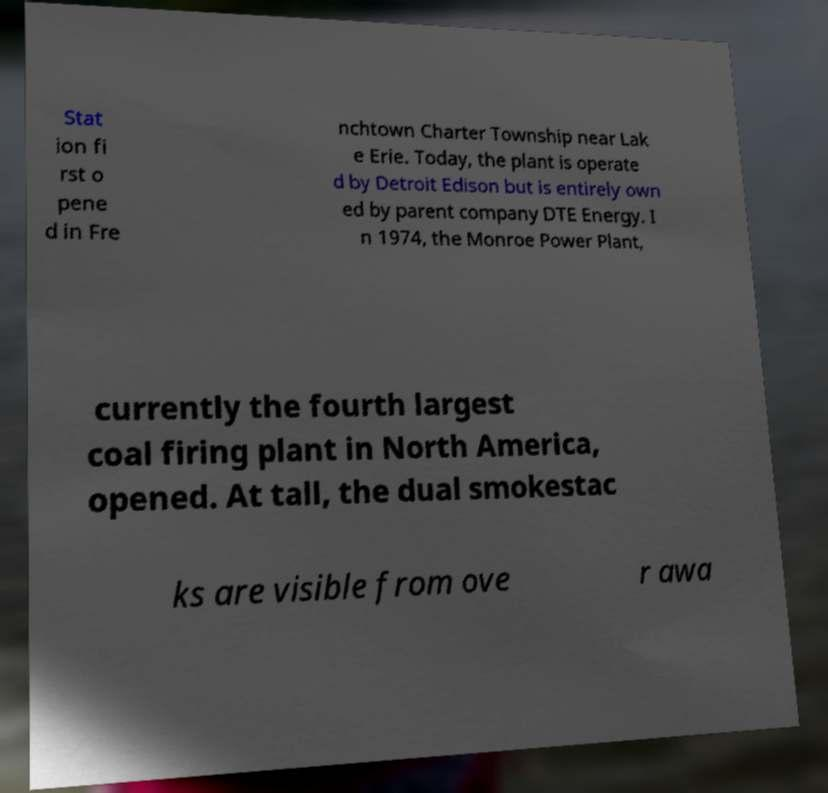There's text embedded in this image that I need extracted. Can you transcribe it verbatim? Stat ion fi rst o pene d in Fre nchtown Charter Township near Lak e Erie. Today, the plant is operate d by Detroit Edison but is entirely own ed by parent company DTE Energy. I n 1974, the Monroe Power Plant, currently the fourth largest coal firing plant in North America, opened. At tall, the dual smokestac ks are visible from ove r awa 